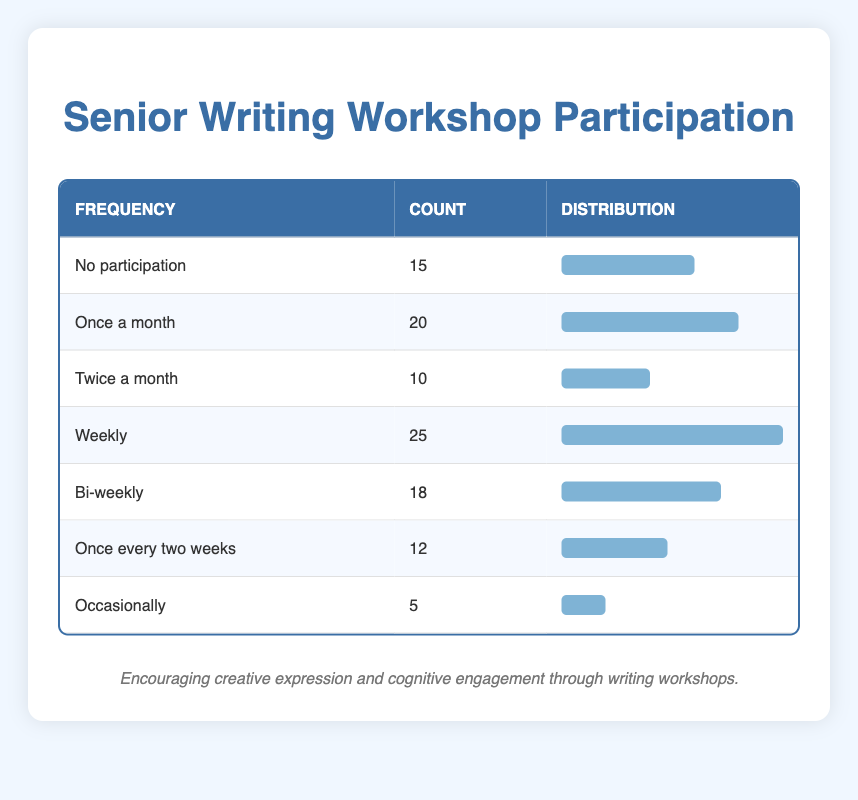What is the total number of participants who never participated in writing workshops? The table shows that the count for "No participation" is 15. Therefore, the total number of participants who never participated is simply that count.
Answer: 15 How many seniors participate in writing workshops at least once a month? To find the participants that join at least once a month, we sum “Once a month” (20), “Twice a month” (10), “Weekly” (25), and “Bi-weekly” (18). The total is 20 + 10 + 25 + 18 = 73.
Answer: 73 Is it true that more seniors participate weekly than those who participate bi-weekly? The count for "Weekly" participation is 25, and the count for "Bi-weekly" participation is 18. Since 25 is greater than 18, the statement is true.
Answer: Yes What percentage of seniors participate occasionally in writing workshops? The count for "Occasionally" is 5. To find the percentage, we need the total count of participants, which is 15 + 20 + 10 + 25 + 18 + 12 + 5 = 95. The percentage is (5 / 95) * 100 ≈ 5.26%.
Answer: Approximately 5.26% What is the average participation frequency among those who participate at least monthly? Participants who join at least monthly are counted as "Once a month" (20), "Twice a month" (10), "Weekly" (25), and "Bi-weekly" (18). The average is calculated via (20 + 10 + 25 + 18) / 4 = 73 / 4 = 18.25.
Answer: 18.25 How many more seniors participate weekly than occasionally? The "Weekly" participation count is 25 and "Occasionally" is 5. To determine the difference, we subtract the two counts: 25 - 5 = 20.
Answer: 20 How many seniors participate in writing workshops twice a month compared to those who participate once every two weeks? The count for "Twice a month" is 10, and for "Once every two weeks" is 12. Since 12 is greater than 10, there are more who participate once every two weeks than twice a month.
Answer: 12 What is the total count of seniors who participate less frequently than bi-weekly? To find seniors participating less frequently than bi-weekly, we consider "Occasionally" (5) and "No participation" (15). The total is 15 + 5 = 20.
Answer: 20 How do the counts of seniors who participate weekly and the combined counts of those who participate bi-weekly and monthly compare? The "Weekly" count is 25. The combined counts of those participating bi-weekly (18), once a month (20), and twice a month (10) total 18 + 20 + 10 = 48. Since 48 is greater than 25, most seniors do not participate weekly.
Answer: 48 > 25 